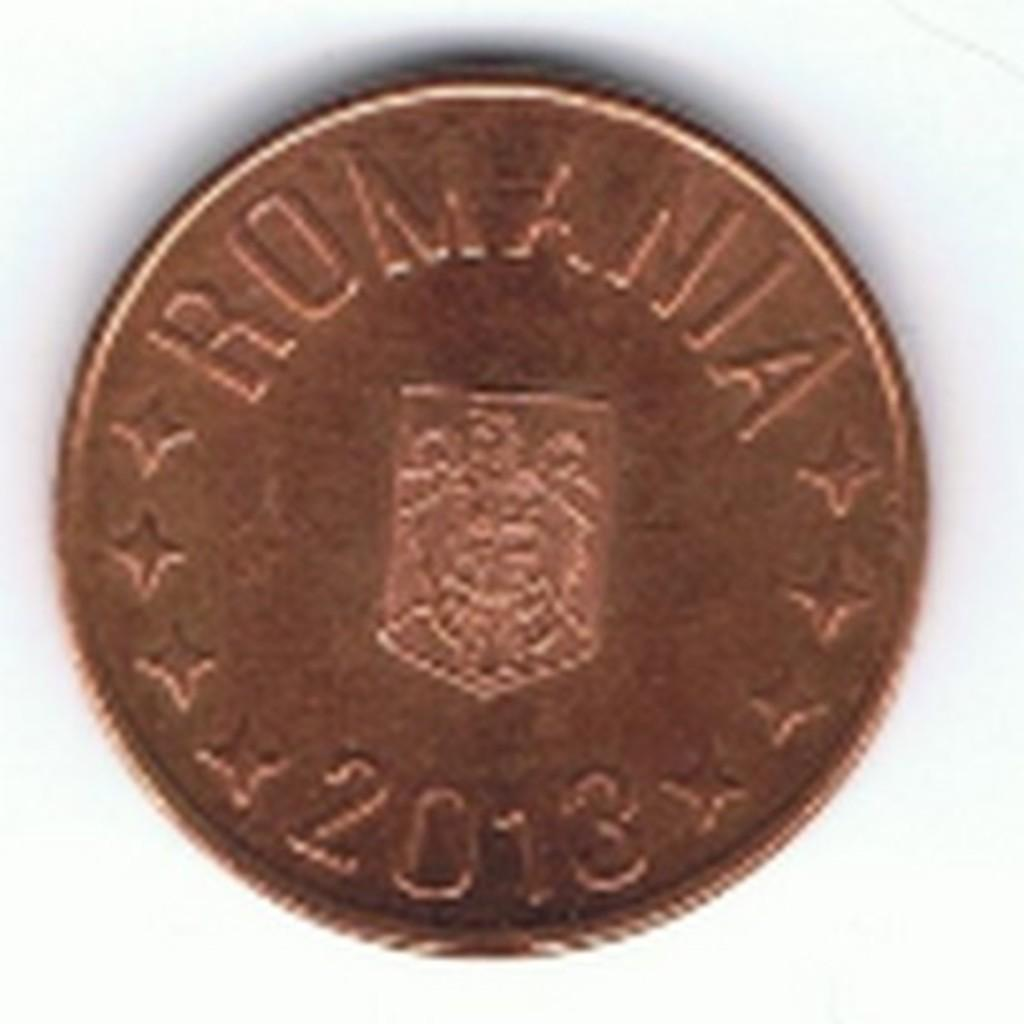<image>
Present a compact description of the photo's key features. A bronze colored coin is imprinted "Romania 2013" 